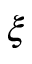Convert formula to latex. <formula><loc_0><loc_0><loc_500><loc_500>\xi</formula> 